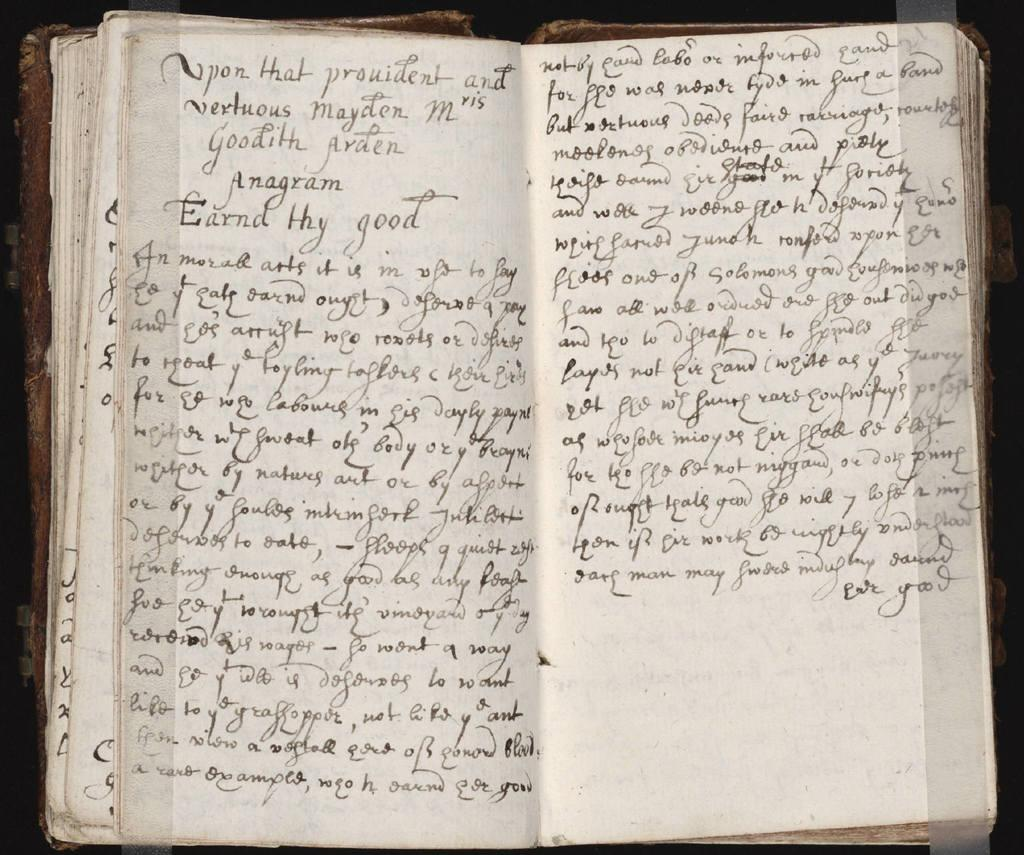<image>
Provide a brief description of the given image. Fancy handwritten words about a maiden cover the pages of a book. 